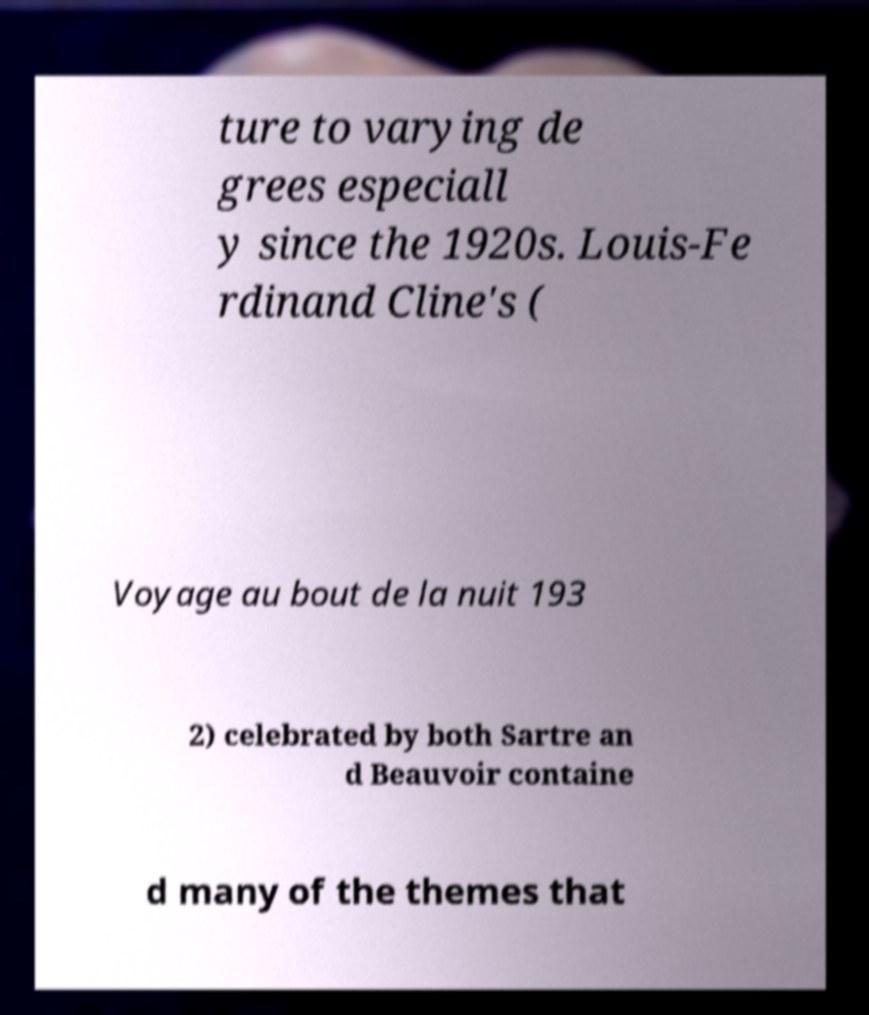I need the written content from this picture converted into text. Can you do that? ture to varying de grees especiall y since the 1920s. Louis-Fe rdinand Cline's ( Voyage au bout de la nuit 193 2) celebrated by both Sartre an d Beauvoir containe d many of the themes that 